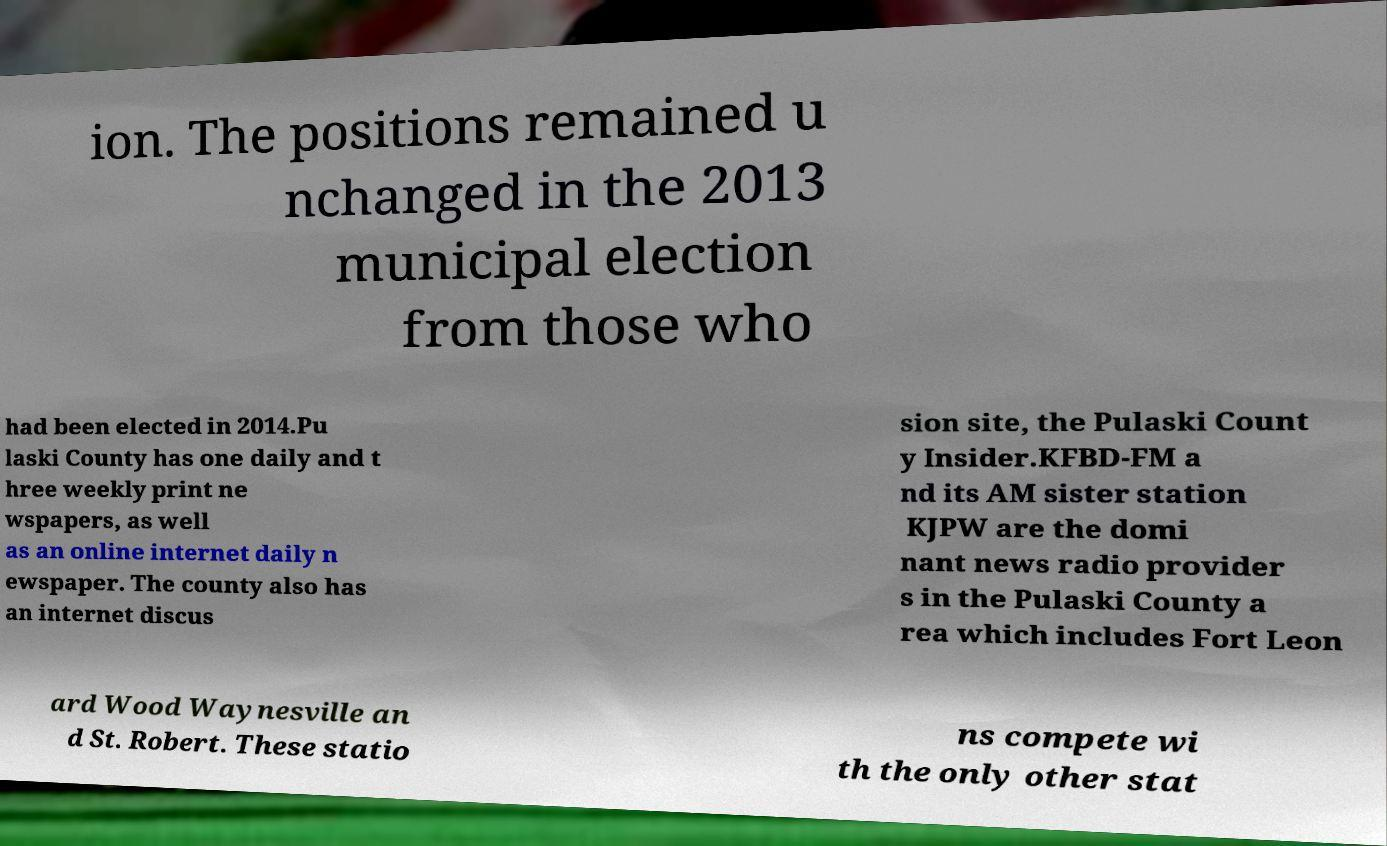What messages or text are displayed in this image? I need them in a readable, typed format. ion. The positions remained u nchanged in the 2013 municipal election from those who had been elected in 2014.Pu laski County has one daily and t hree weekly print ne wspapers, as well as an online internet daily n ewspaper. The county also has an internet discus sion site, the Pulaski Count y Insider.KFBD-FM a nd its AM sister station KJPW are the domi nant news radio provider s in the Pulaski County a rea which includes Fort Leon ard Wood Waynesville an d St. Robert. These statio ns compete wi th the only other stat 